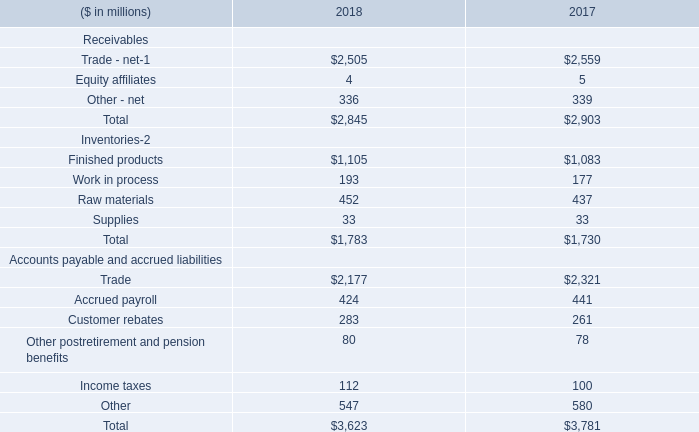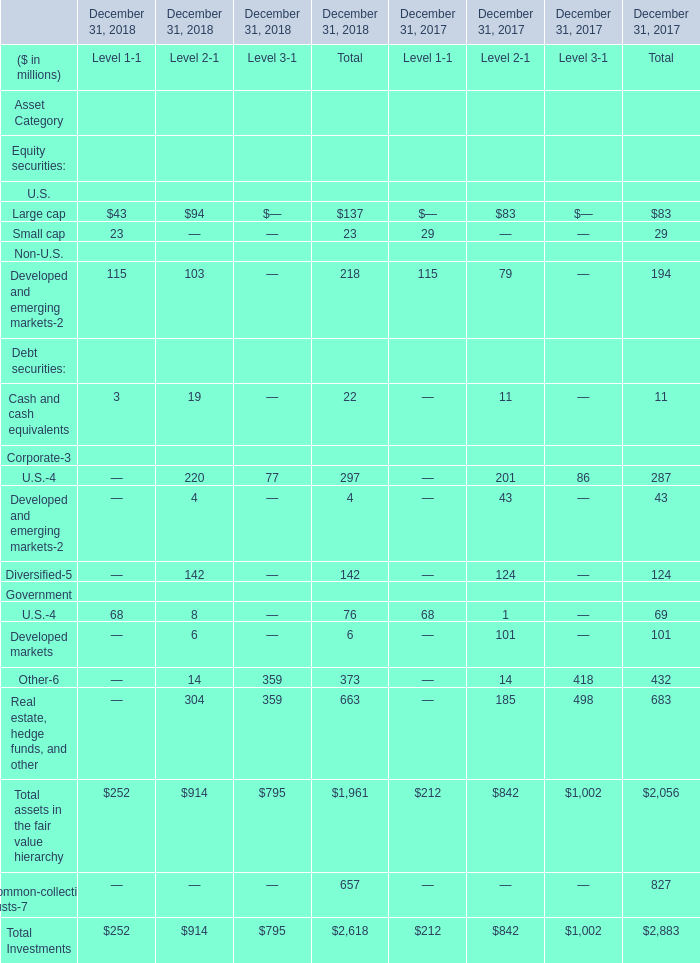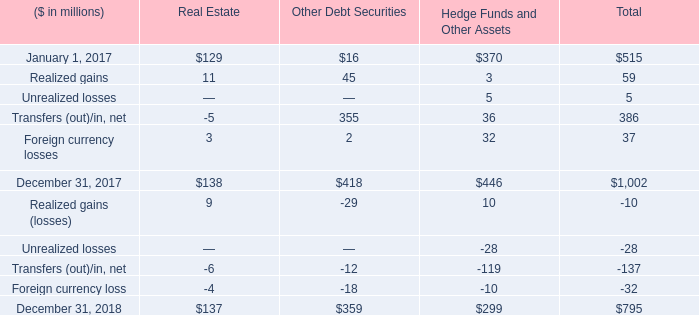At December 31, 2018,which Level is Total assets in the fair value hierarchy the least? 
Answer: 1. 